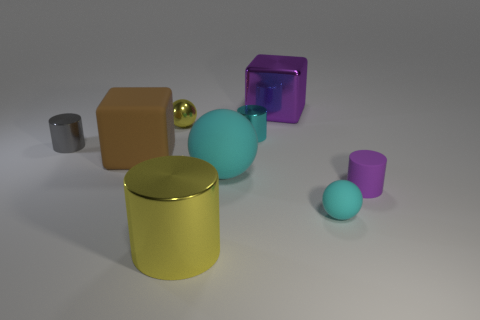There is a small ball in front of the small purple matte cylinder; is its color the same as the large matte sphere?
Your answer should be very brief. Yes. Are there any balls that have the same color as the big metal cylinder?
Your response must be concise. Yes. Is the matte cylinder the same color as the large metallic cube?
Your answer should be compact. Yes. There is a cylinder that is both on the right side of the gray metal object and behind the big cyan matte thing; how big is it?
Offer a terse response. Small. There is a large object that is made of the same material as the large brown block; what color is it?
Your response must be concise. Cyan. What number of large gray things are made of the same material as the purple cylinder?
Your answer should be very brief. 0. Is the number of cyan cylinders in front of the big metal cylinder the same as the number of small gray metal things to the right of the small yellow thing?
Ensure brevity in your answer.  Yes. Is the shape of the brown rubber thing the same as the small metal thing to the left of the large brown matte thing?
Ensure brevity in your answer.  No. There is a small thing that is the same color as the metallic cube; what is its material?
Offer a terse response. Rubber. Is the material of the tiny gray thing the same as the small cylinder that is in front of the small gray object?
Provide a succinct answer. No. 